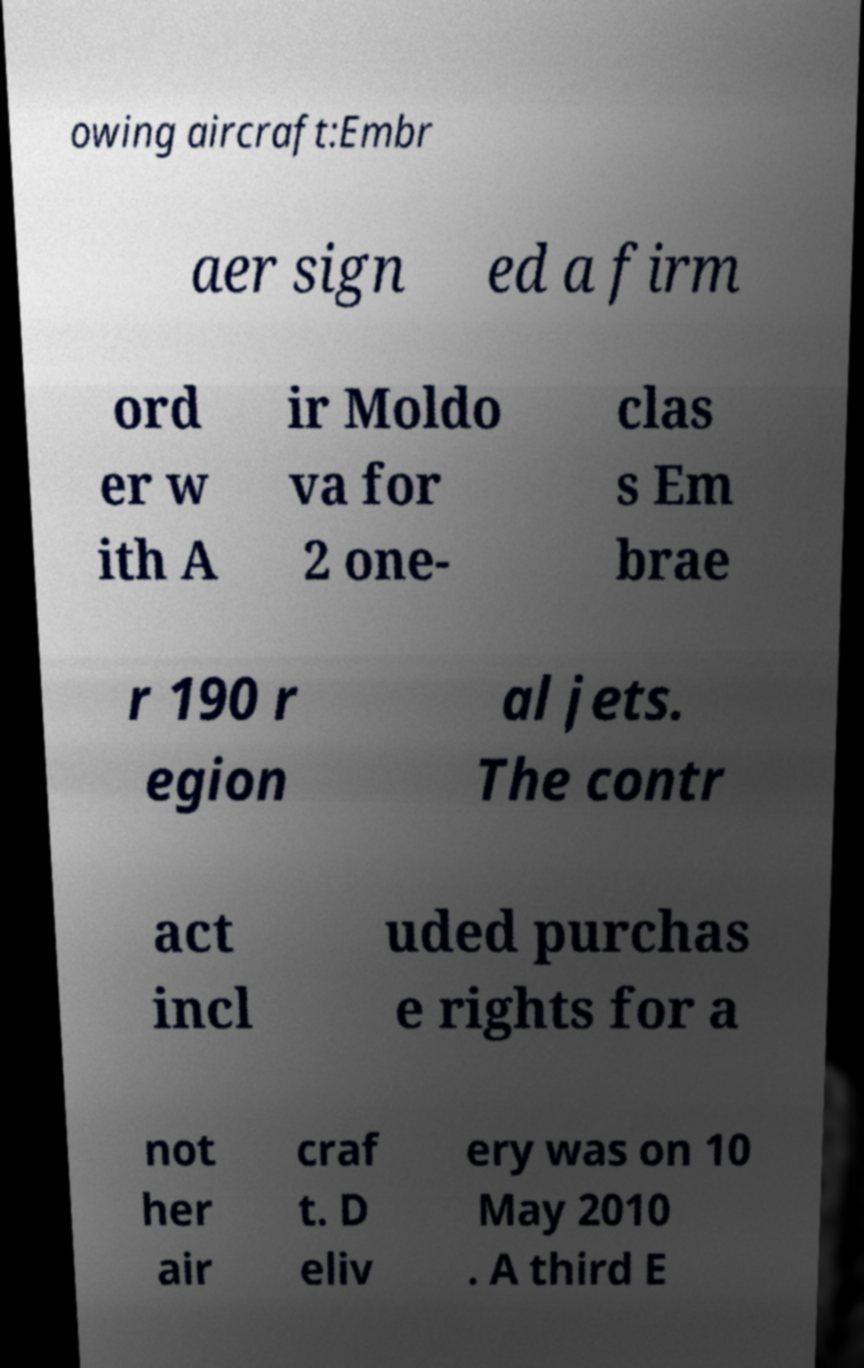There's text embedded in this image that I need extracted. Can you transcribe it verbatim? owing aircraft:Embr aer sign ed a firm ord er w ith A ir Moldo va for 2 one- clas s Em brae r 190 r egion al jets. The contr act incl uded purchas e rights for a not her air craf t. D eliv ery was on 10 May 2010 . A third E 